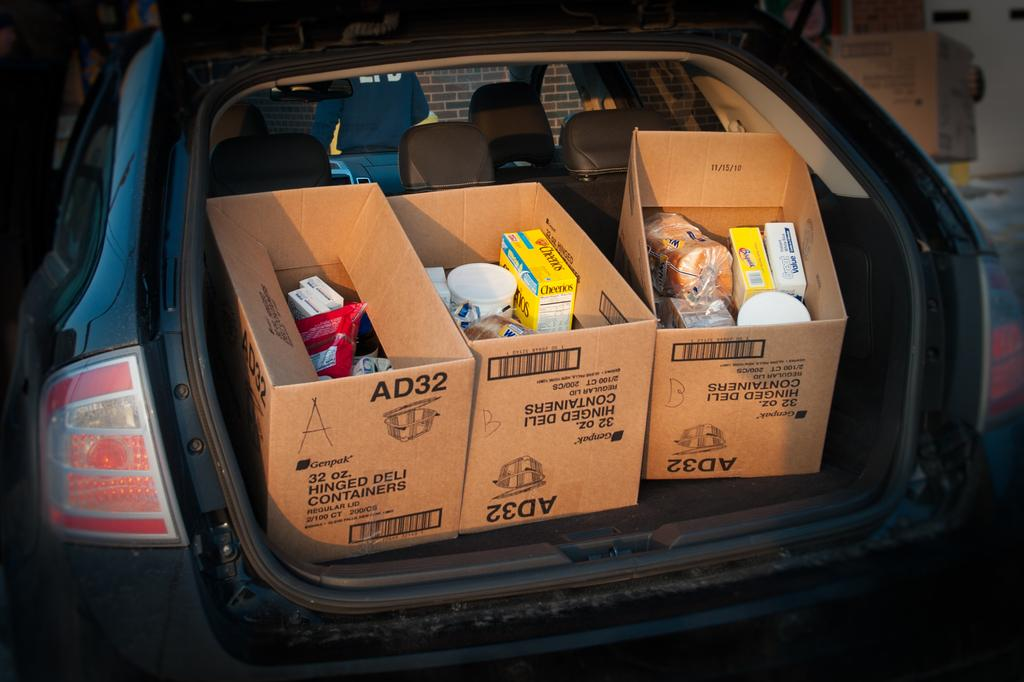What is the main subject of the image? The main subject of the image is a car. What can be found inside the car? There are boxes with objects in the car. Can you describe the background of the image? There is a person and a wall in the background of the image. What is the income of the person in the image? There is no information about the person's income in the image. How many birds are in the flock in the image? There are no birds or flocks present in the image. 